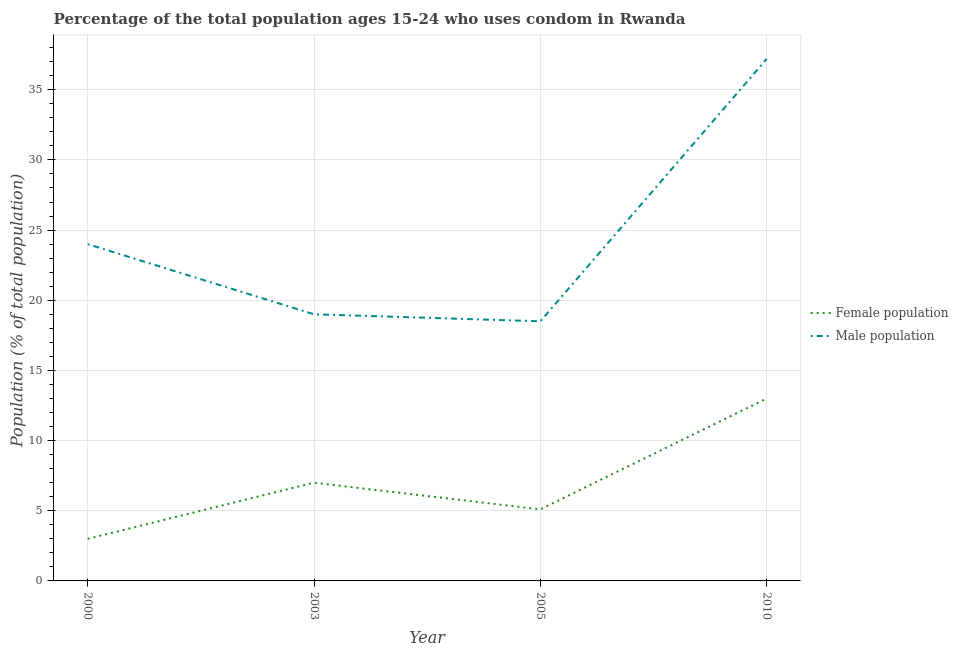Across all years, what is the maximum male population?
Your answer should be very brief. 37.2. In which year was the male population maximum?
Keep it short and to the point. 2010. In which year was the male population minimum?
Your response must be concise. 2005. What is the total female population in the graph?
Provide a short and direct response. 28.1. What is the difference between the female population in 2003 and that in 2010?
Your answer should be compact. -6. What is the difference between the male population in 2005 and the female population in 2010?
Your response must be concise. 5.5. What is the average female population per year?
Your answer should be compact. 7.03. In how many years, is the male population greater than 19 %?
Ensure brevity in your answer.  2. What is the ratio of the male population in 2003 to that in 2005?
Provide a succinct answer. 1.03. Is the female population in 2000 less than that in 2003?
Ensure brevity in your answer.  Yes. What is the difference between the highest and the lowest female population?
Your answer should be very brief. 10. In how many years, is the female population greater than the average female population taken over all years?
Make the answer very short. 1. Does the male population monotonically increase over the years?
Provide a short and direct response. No. How many lines are there?
Your answer should be compact. 2. What is the difference between two consecutive major ticks on the Y-axis?
Your answer should be very brief. 5. Are the values on the major ticks of Y-axis written in scientific E-notation?
Your answer should be compact. No. How many legend labels are there?
Provide a short and direct response. 2. How are the legend labels stacked?
Your response must be concise. Vertical. What is the title of the graph?
Offer a terse response. Percentage of the total population ages 15-24 who uses condom in Rwanda. What is the label or title of the Y-axis?
Your answer should be compact. Population (% of total population) . What is the Population (% of total population)  of Female population in 2005?
Your answer should be very brief. 5.1. What is the Population (% of total population)  of Male population in 2005?
Your response must be concise. 18.5. What is the Population (% of total population)  of Male population in 2010?
Provide a short and direct response. 37.2. Across all years, what is the maximum Population (% of total population)  of Male population?
Your answer should be compact. 37.2. What is the total Population (% of total population)  of Female population in the graph?
Provide a short and direct response. 28.1. What is the total Population (% of total population)  of Male population in the graph?
Your answer should be compact. 98.7. What is the difference between the Population (% of total population)  of Female population in 2000 and that in 2003?
Offer a very short reply. -4. What is the difference between the Population (% of total population)  of Female population in 2000 and that in 2005?
Offer a terse response. -2.1. What is the difference between the Population (% of total population)  of Male population in 2000 and that in 2005?
Offer a terse response. 5.5. What is the difference between the Population (% of total population)  in Male population in 2000 and that in 2010?
Give a very brief answer. -13.2. What is the difference between the Population (% of total population)  of Female population in 2003 and that in 2005?
Make the answer very short. 1.9. What is the difference between the Population (% of total population)  in Male population in 2003 and that in 2010?
Your answer should be very brief. -18.2. What is the difference between the Population (% of total population)  of Male population in 2005 and that in 2010?
Make the answer very short. -18.7. What is the difference between the Population (% of total population)  in Female population in 2000 and the Population (% of total population)  in Male population in 2003?
Ensure brevity in your answer.  -16. What is the difference between the Population (% of total population)  in Female population in 2000 and the Population (% of total population)  in Male population in 2005?
Keep it short and to the point. -15.5. What is the difference between the Population (% of total population)  of Female population in 2000 and the Population (% of total population)  of Male population in 2010?
Ensure brevity in your answer.  -34.2. What is the difference between the Population (% of total population)  in Female population in 2003 and the Population (% of total population)  in Male population in 2010?
Provide a succinct answer. -30.2. What is the difference between the Population (% of total population)  of Female population in 2005 and the Population (% of total population)  of Male population in 2010?
Your answer should be compact. -32.1. What is the average Population (% of total population)  of Female population per year?
Your answer should be very brief. 7.03. What is the average Population (% of total population)  in Male population per year?
Your answer should be very brief. 24.68. In the year 2003, what is the difference between the Population (% of total population)  of Female population and Population (% of total population)  of Male population?
Your answer should be very brief. -12. In the year 2010, what is the difference between the Population (% of total population)  of Female population and Population (% of total population)  of Male population?
Provide a succinct answer. -24.2. What is the ratio of the Population (% of total population)  in Female population in 2000 to that in 2003?
Your answer should be very brief. 0.43. What is the ratio of the Population (% of total population)  of Male population in 2000 to that in 2003?
Your answer should be very brief. 1.26. What is the ratio of the Population (% of total population)  in Female population in 2000 to that in 2005?
Ensure brevity in your answer.  0.59. What is the ratio of the Population (% of total population)  of Male population in 2000 to that in 2005?
Your response must be concise. 1.3. What is the ratio of the Population (% of total population)  of Female population in 2000 to that in 2010?
Give a very brief answer. 0.23. What is the ratio of the Population (% of total population)  in Male population in 2000 to that in 2010?
Offer a very short reply. 0.65. What is the ratio of the Population (% of total population)  of Female population in 2003 to that in 2005?
Ensure brevity in your answer.  1.37. What is the ratio of the Population (% of total population)  in Male population in 2003 to that in 2005?
Keep it short and to the point. 1.03. What is the ratio of the Population (% of total population)  of Female population in 2003 to that in 2010?
Ensure brevity in your answer.  0.54. What is the ratio of the Population (% of total population)  in Male population in 2003 to that in 2010?
Give a very brief answer. 0.51. What is the ratio of the Population (% of total population)  in Female population in 2005 to that in 2010?
Your answer should be very brief. 0.39. What is the ratio of the Population (% of total population)  of Male population in 2005 to that in 2010?
Give a very brief answer. 0.5. What is the difference between the highest and the second highest Population (% of total population)  of Female population?
Your answer should be very brief. 6. 